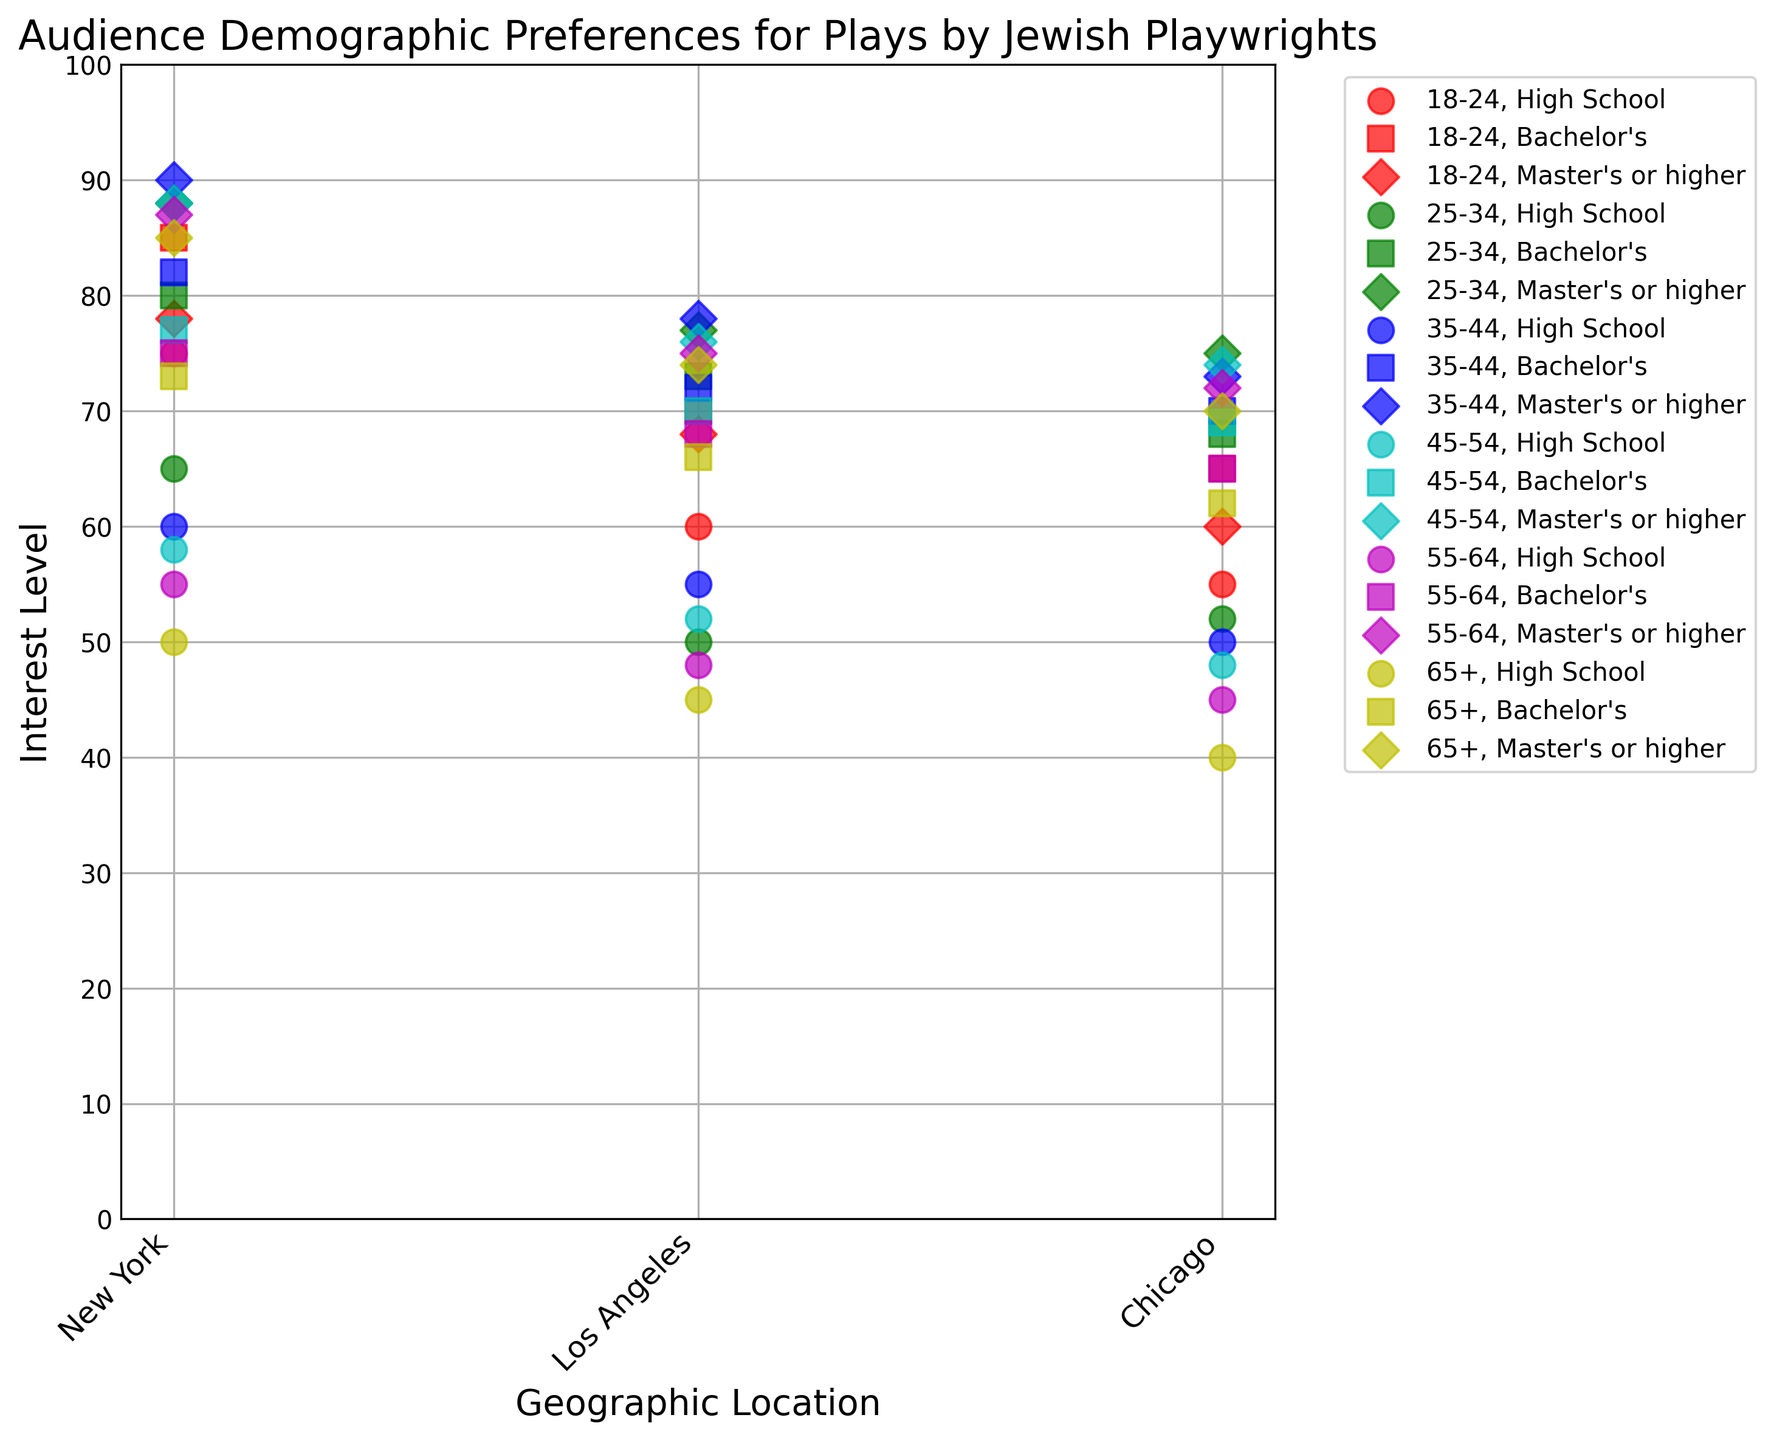What is the average interest level of viewers aged 25-34 with a Master's or higher degree in New York and Chicago? To find the average interest level, sum the interest levels of the specified groups and divide by the number of groups. For New York and Chicago with a Master's or higher degree aged 25-34, the interest levels are 88 and 75 respectively. Sum: 88 + 75 = 163. Divide by 2: 163 / 2 = 81.5
Answer: 81.5 Which geographic location has the highest interest level among viewers aged 18-24 with a Bachelor's degree? From the plot, we can see that the interest levels of viewers aged 18-24 with a Bachelor's degree are plotted for New York (85), Los Angeles (70), and Chicago (65). The highest value is 85 in New York.
Answer: New York For viewers aged 45-54 with a High School education, which city has the lowest interest level? The interest levels for viewers aged 45-54 with a High School education are observed for New York (58), Los Angeles (52), and Chicago (48). The lowest value is 48, observed in Chicago.
Answer: Chicago Compare the interest levels for viewers aged 35-44 with a Master's or higher degree in Los Angeles and Chicago. Which location has a higher interest level and by how much? From the visual plot, the interest levels are 78 for Los Angeles and 73 for Chicago. To determine the difference, subtract the lower value from the higher value: 78 - 73 = 5. Los Angeles has the higher interest level by 5 points.
Answer: Los Angeles, 5 points What is the trend in interest levels for viewers aged 65+ with a Bachelor's degree across all three cities? For viewers aged 65+ with a Bachelor's degree, observe the interest levels: New York (73), Los Angeles (66), and Chicago (62). The trend shows a decreasing pattern from New York to Chicago.
Answer: Decreasing How does the interest level of viewers aged 55-64 with a Master's or higher degree in Los Angeles compare to that of viewers aged 65+ with the same education level in the same city? From the plot, find the interest levels: 55-64 with a Master's or higher degree in Los Angeles (75), and 65+ with a Master's or higher degree in Los Angeles (74). Compare these values: 75 > 74.
Answer: Higher by 1 Which age group has the highest average interest level in New York regardless of education level? First, aggregate the interest levels for each age group in New York, then calculate the average:
18-24: (75 + 85 + 78) / 3 = 79.33;
25-34: (65 + 80 + 88) / 3 = 77.67;
35-44: (60 + 82 + 90) / 3 = 77.33;
45-54: (58 + 77 + 88) / 3 = 74.33;
55-64: (55 + 75 + 87) / 3 = 72.33;
65+: (50 + 73 + 85) / 3 = 69.33.
The highest average is for age group 18-24 (79.33).
Answer: 18-24 What is the overall trend in interest levels as age increases for viewers in Chicago with a Bachelor's degree? Review the interest levels for all age groups in Chicago with a Bachelor's degree: 
18-24 (65), 25-34 (68), 35-44 (70), 45-54 (69), 55-64 (65), 65+ (62). The trend mostly decreases as age increases, with a high point at age 35-44.
Answer: Decreasing What visual marker represents viewers with a Bachelor's degree, and how are the interest levels differentiated by colors? The plot assigns unique markers and colors to differentiate demographic groups. For Bachelor's degrees, the marker is consistent within each education group. Colors differentiate interest levels by age group, with a pattern observed across the plot. This visual helps in easily identifying and comparing groups.
Answer: Marker for Bachelor's: consistent, Colors: differentiate by age 